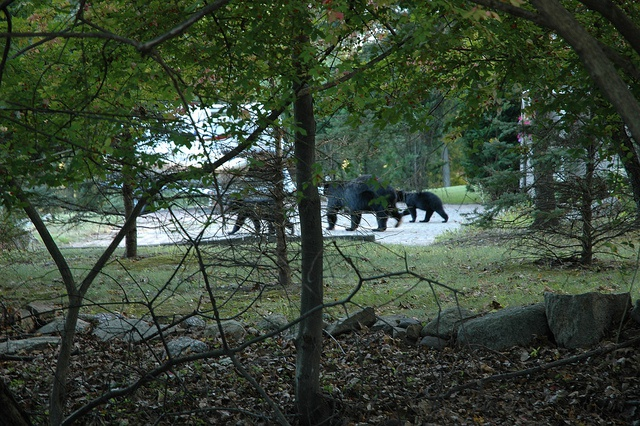Describe the objects in this image and their specific colors. I can see bear in black, blue, darkblue, and purple tones, bear in black, gray, and purple tones, and bear in black, darkblue, gray, and blue tones in this image. 